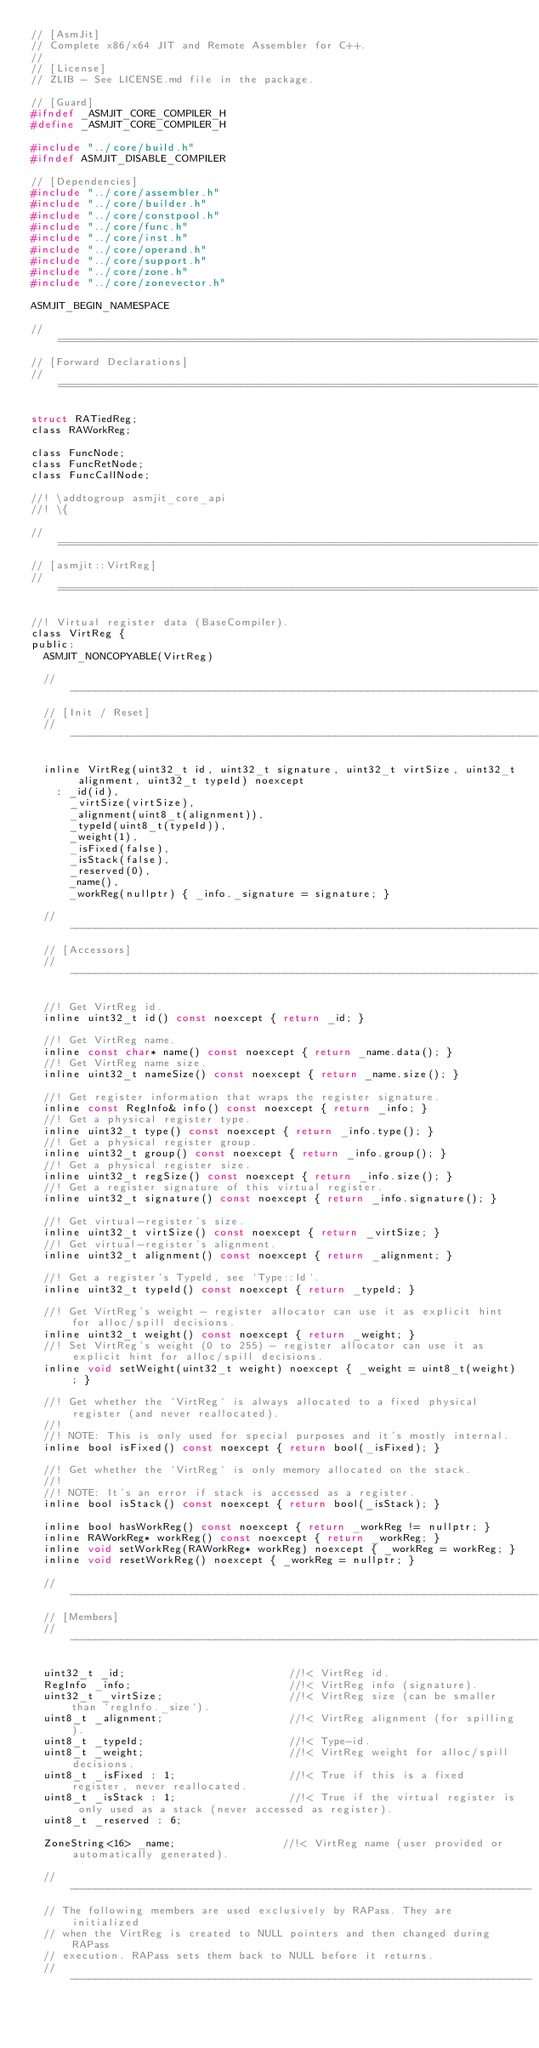<code> <loc_0><loc_0><loc_500><loc_500><_C_>// [AsmJit]
// Complete x86/x64 JIT and Remote Assembler for C++.
//
// [License]
// ZLIB - See LICENSE.md file in the package.

// [Guard]
#ifndef _ASMJIT_CORE_COMPILER_H
#define _ASMJIT_CORE_COMPILER_H

#include "../core/build.h"
#ifndef ASMJIT_DISABLE_COMPILER

// [Dependencies]
#include "../core/assembler.h"
#include "../core/builder.h"
#include "../core/constpool.h"
#include "../core/func.h"
#include "../core/inst.h"
#include "../core/operand.h"
#include "../core/support.h"
#include "../core/zone.h"
#include "../core/zonevector.h"

ASMJIT_BEGIN_NAMESPACE

// ============================================================================
// [Forward Declarations]
// ============================================================================

struct RATiedReg;
class RAWorkReg;

class FuncNode;
class FuncRetNode;
class FuncCallNode;

//! \addtogroup asmjit_core_api
//! \{

// ============================================================================
// [asmjit::VirtReg]
// ============================================================================

//! Virtual register data (BaseCompiler).
class VirtReg {
public:
  ASMJIT_NONCOPYABLE(VirtReg)

  // --------------------------------------------------------------------------
  // [Init / Reset]
  // --------------------------------------------------------------------------

  inline VirtReg(uint32_t id, uint32_t signature, uint32_t virtSize, uint32_t alignment, uint32_t typeId) noexcept
    : _id(id),
      _virtSize(virtSize),
      _alignment(uint8_t(alignment)),
      _typeId(uint8_t(typeId)),
      _weight(1),
      _isFixed(false),
      _isStack(false),
      _reserved(0),
      _name(),
      _workReg(nullptr) { _info._signature = signature; }

  // --------------------------------------------------------------------------
  // [Accessors]
  // --------------------------------------------------------------------------

  //! Get VirtReg id.
  inline uint32_t id() const noexcept { return _id; }

  //! Get VirtReg name.
  inline const char* name() const noexcept { return _name.data(); }
  //! Get VirtReg name size.
  inline uint32_t nameSize() const noexcept { return _name.size(); }

  //! Get register information that wraps the register signature.
  inline const RegInfo& info() const noexcept { return _info; }
  //! Get a physical register type.
  inline uint32_t type() const noexcept { return _info.type(); }
  //! Get a physical register group.
  inline uint32_t group() const noexcept { return _info.group(); }
  //! Get a physical register size.
  inline uint32_t regSize() const noexcept { return _info.size(); }
  //! Get a register signature of this virtual register.
  inline uint32_t signature() const noexcept { return _info.signature(); }

  //! Get virtual-register's size.
  inline uint32_t virtSize() const noexcept { return _virtSize; }
  //! Get virtual-register's alignment.
  inline uint32_t alignment() const noexcept { return _alignment; }

  //! Get a register's TypeId, see `Type::Id`.
  inline uint32_t typeId() const noexcept { return _typeId; }

  //! Get VirtReg's weight - register allocator can use it as explicit hint for alloc/spill decisions.
  inline uint32_t weight() const noexcept { return _weight; }
  //! Set VirtReg's weight (0 to 255) - register allocator can use it as explicit hint for alloc/spill decisions.
  inline void setWeight(uint32_t weight) noexcept { _weight = uint8_t(weight); }

  //! Get whether the `VirtReg` is always allocated to a fixed physical register (and never reallocated).
  //!
  //! NOTE: This is only used for special purposes and it's mostly internal.
  inline bool isFixed() const noexcept { return bool(_isFixed); }

  //! Get whether the `VirtReg` is only memory allocated on the stack.
  //!
  //! NOTE: It's an error if stack is accessed as a register.
  inline bool isStack() const noexcept { return bool(_isStack); }

  inline bool hasWorkReg() const noexcept { return _workReg != nullptr; }
  inline RAWorkReg* workReg() const noexcept { return _workReg; }
  inline void setWorkReg(RAWorkReg* workReg) noexcept { _workReg = workReg; }
  inline void resetWorkReg() noexcept { _workReg = nullptr; }

  // --------------------------------------------------------------------------
  // [Members]
  // --------------------------------------------------------------------------

  uint32_t _id;                          //!< VirtReg id.
  RegInfo _info;                         //!< VirtReg info (signature).
  uint32_t _virtSize;                    //!< VirtReg size (can be smaller than `regInfo._size`).
  uint8_t _alignment;                    //!< VirtReg alignment (for spilling).
  uint8_t _typeId;                       //!< Type-id.
  uint8_t _weight;                       //!< VirtReg weight for alloc/spill decisions.
  uint8_t _isFixed : 1;                  //!< True if this is a fixed register, never reallocated.
  uint8_t _isStack : 1;                  //!< True if the virtual register is only used as a stack (never accessed as register).
  uint8_t _reserved : 6;

  ZoneString<16> _name;                 //!< VirtReg name (user provided or automatically generated).

  // -------------------------------------------------------------------------
  // The following members are used exclusively by RAPass. They are initialized
  // when the VirtReg is created to NULL pointers and then changed during RAPass
  // execution. RAPass sets them back to NULL before it returns.
  // -------------------------------------------------------------------------
</code> 